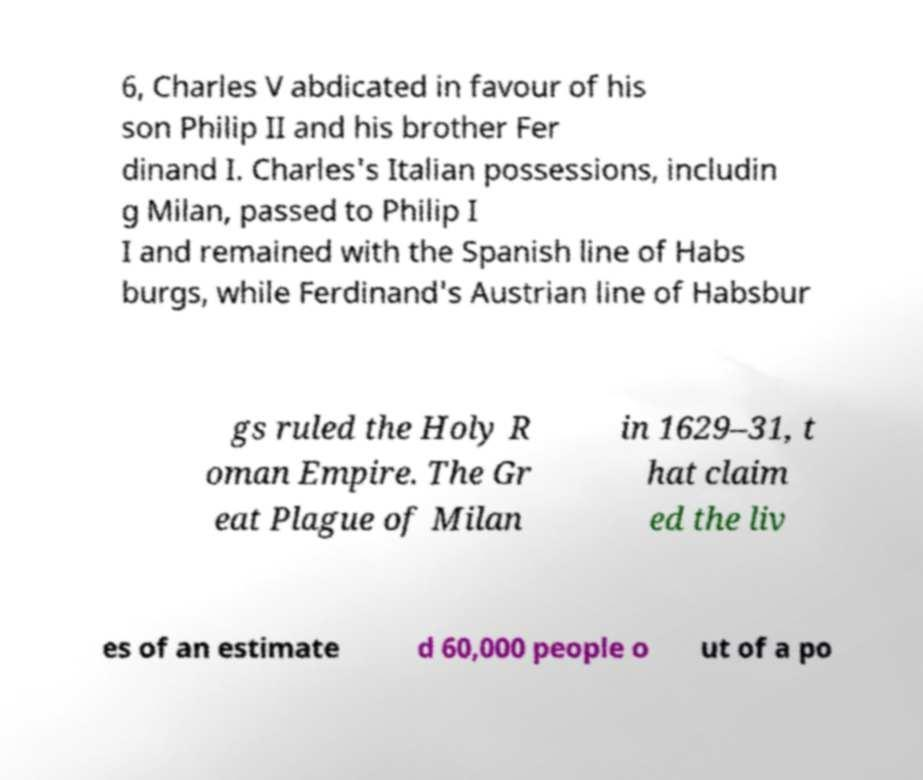I need the written content from this picture converted into text. Can you do that? 6, Charles V abdicated in favour of his son Philip II and his brother Fer dinand I. Charles's Italian possessions, includin g Milan, passed to Philip I I and remained with the Spanish line of Habs burgs, while Ferdinand's Austrian line of Habsbur gs ruled the Holy R oman Empire. The Gr eat Plague of Milan in 1629–31, t hat claim ed the liv es of an estimate d 60,000 people o ut of a po 